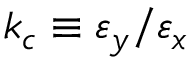Convert formula to latex. <formula><loc_0><loc_0><loc_500><loc_500>k _ { c } \equiv \varepsilon _ { y } / \varepsilon _ { x }</formula> 